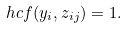Convert formula to latex. <formula><loc_0><loc_0><loc_500><loc_500>\ h c f ( y _ { i } , z _ { i j } ) = 1 .</formula> 